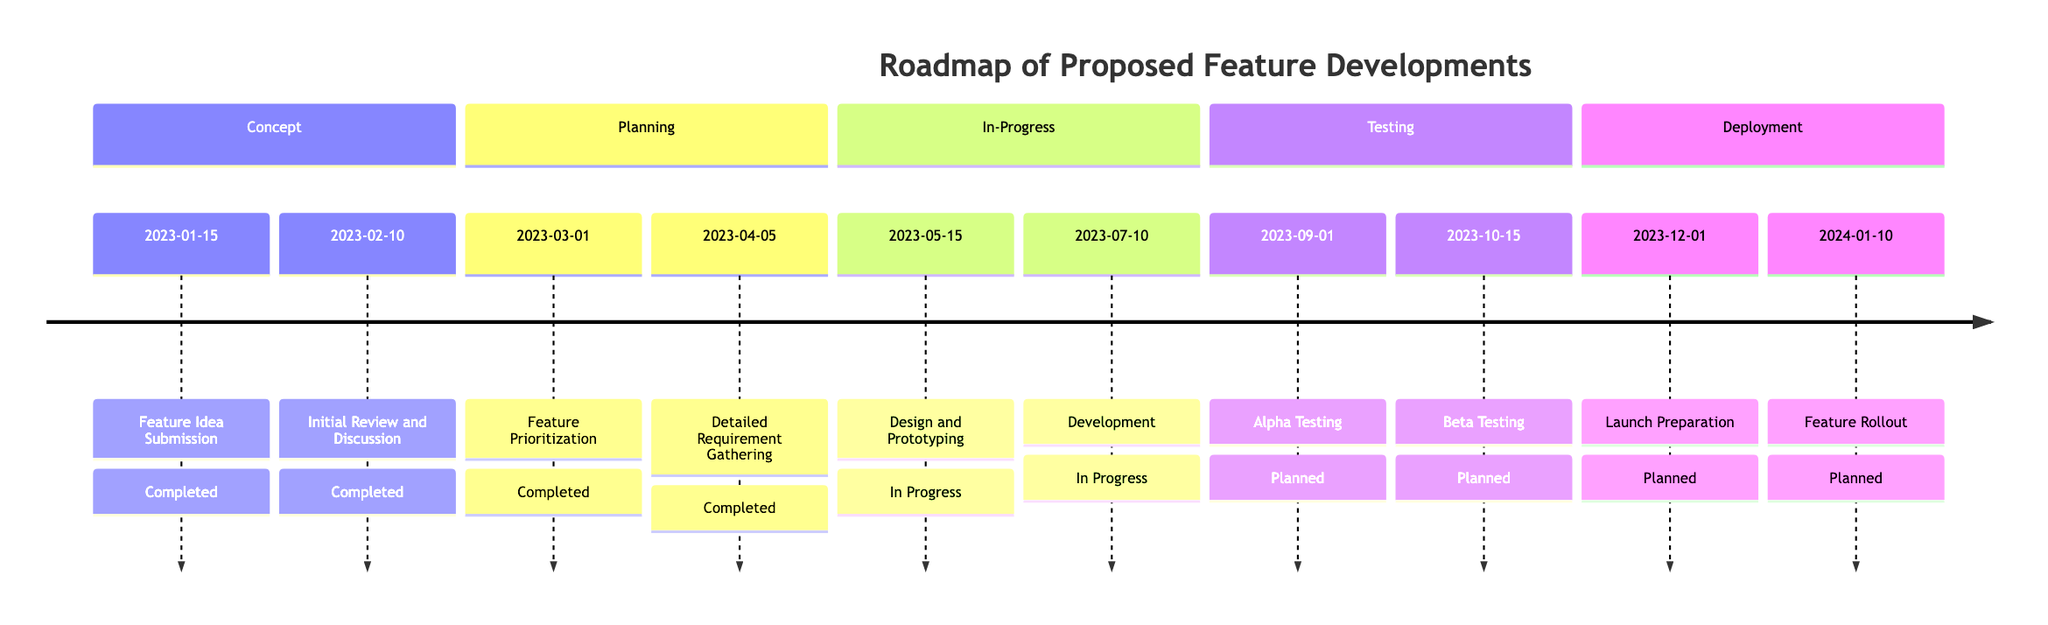What stage does "Feature Idea Submission" belong to? "Feature Idea Submission" is listed under the "Concept" stage in the timeline.
Answer: Concept How many total elements are in the "Planning" stage? There are two elements in the "Planning" stage: "Feature Prioritization" and "Detailed Requirement Gathering".
Answer: 2 What is the status of the "Beta Testing" element? The status of "Beta Testing" is "planned", as indicated in the timeline under the "Testing" stage.
Answer: planned Which element is scheduled to occur on 2023-10-15? "Beta Testing" is scheduled for 2023-10-15, according to the timeline.
Answer: Beta Testing What is the earliest completion date in the timeline? The earliest completion date is 2023-01-15, which corresponds to the "Feature Idea Submission".
Answer: 2023-01-15 Which two stages contain elements that are currently in progress? The "In-Progress" stage contains both "Design and Prototyping" and "Development", which are currently in progress.
Answer: In-Progress What is the last planned event before the "Feature Rollout"? The last planned event before "Feature Rollout" is "Launch Preparation", scheduled for 2023-12-01.
Answer: Launch Preparation How many elements are planned for the "Testing" stage? There are two planned elements in the "Testing" stage: "Alpha Testing" and "Beta Testing".
Answer: 2 Which stage does the "Development" element belong to? The "Development" element belongs to the "In-Progress" stage of the timeline.
Answer: In-Progress 